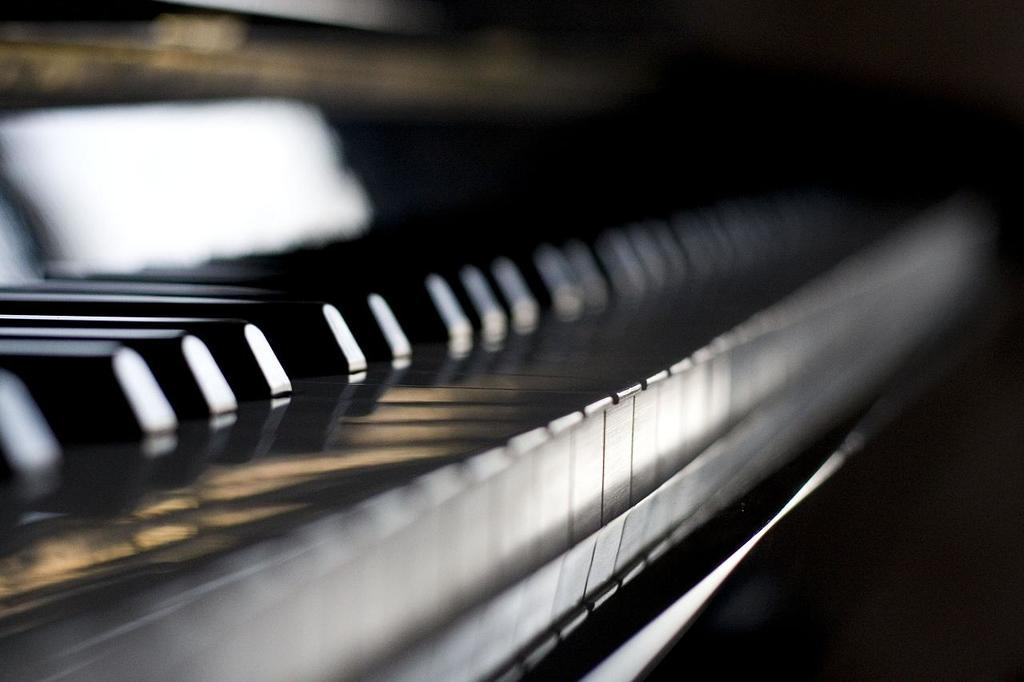What type of object is the main subject in the image? There is a musical instrument in the image. Can you describe the white object on the top left side of the image? The white object on the top left side of the image is not clearly identifiable due to the image being blurry. How would you describe the overall quality of the image? The image is blurry. What type of lead can be seen in the image? There is no lead present in the image. How does the musical instrument start playing in the image? The image does not show the musical instrument playing, so it is not possible to determine how it starts playing. 